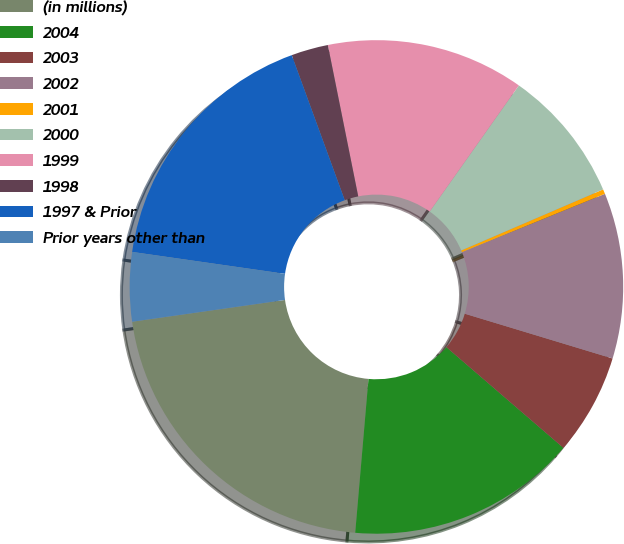<chart> <loc_0><loc_0><loc_500><loc_500><pie_chart><fcel>(in millions)<fcel>2004<fcel>2003<fcel>2002<fcel>2001<fcel>2000<fcel>1999<fcel>1998<fcel>1997 & Prior<fcel>Prior years other than<nl><fcel>21.38%<fcel>15.06%<fcel>6.63%<fcel>10.84%<fcel>0.31%<fcel>8.74%<fcel>12.95%<fcel>2.42%<fcel>17.16%<fcel>4.52%<nl></chart> 